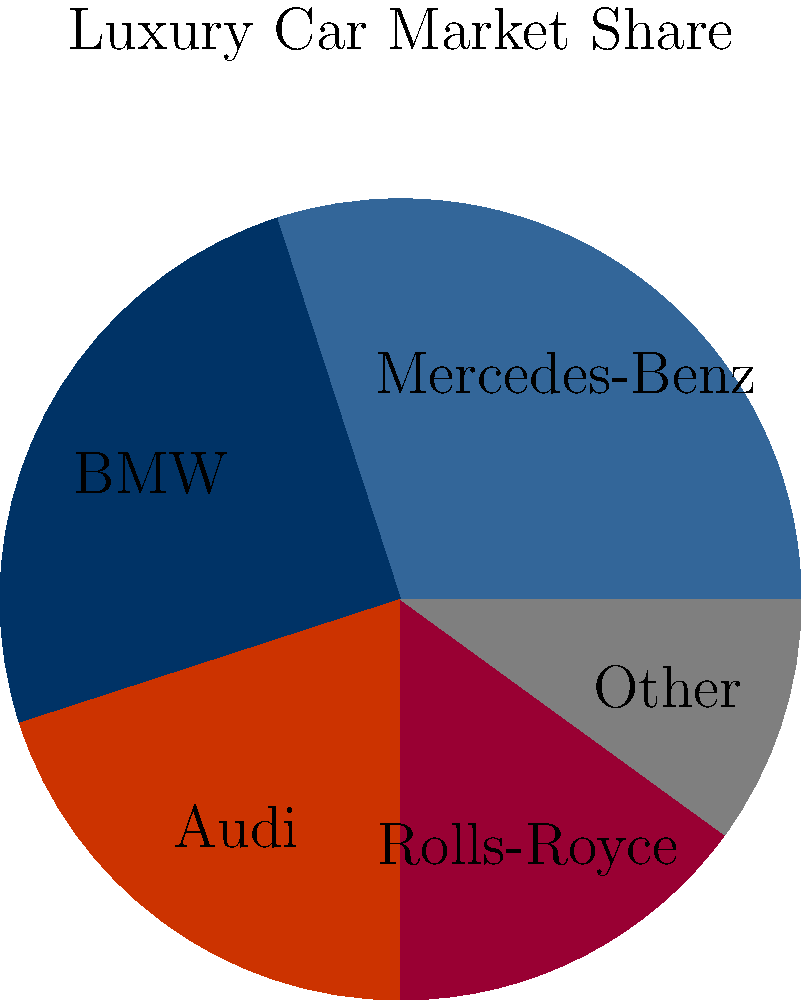Based on the pie chart showing luxury car market share, which brand has the largest market share, and how does Rolls-Royce's share compare to the market leader? To answer this question, let's analyze the pie chart step-by-step:

1. Identify the market leader:
   - Mercedes-Benz has the largest slice, representing 30% of the market share.

2. Locate Rolls-Royce's market share:
   - Rolls-Royce has a 15% market share, represented by the purple slice.

3. Compare Rolls-Royce to the market leader:
   - Mercedes-Benz (leader): 30%
   - Rolls-Royce: 15%
   - Difference: 30% - 15% = 15%

4. Express the comparison:
   - Rolls-Royce's market share is half of Mercedes-Benz's.
   - Mathematically: $\frac{15\%}{30\%} = \frac{1}{2}$ or 50%

Thus, Mercedes-Benz leads the luxury car market with a 30% share, while Rolls-Royce holds half of that at 15%.
Answer: Mercedes-Benz leads; Rolls-Royce's share is half of Mercedes-Benz's. 